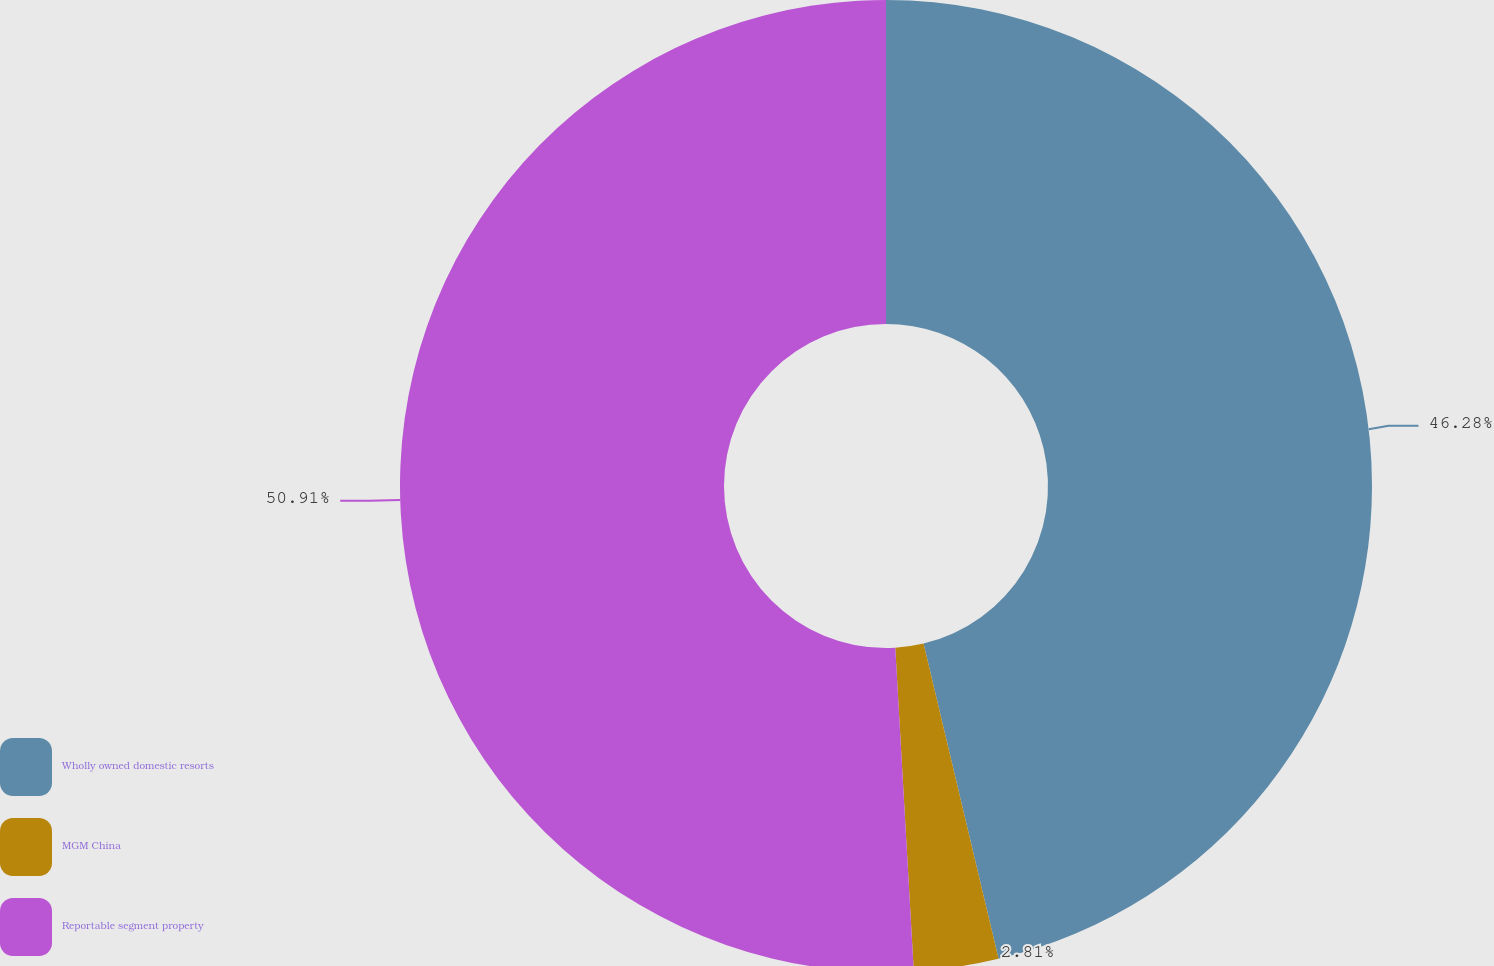Convert chart. <chart><loc_0><loc_0><loc_500><loc_500><pie_chart><fcel>Wholly owned domestic resorts<fcel>MGM China<fcel>Reportable segment property<nl><fcel>46.28%<fcel>2.81%<fcel>50.91%<nl></chart> 